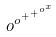<formula> <loc_0><loc_0><loc_500><loc_500>o ^ { o ^ { + ^ { + ^ { o ^ { x } } } } }</formula> 